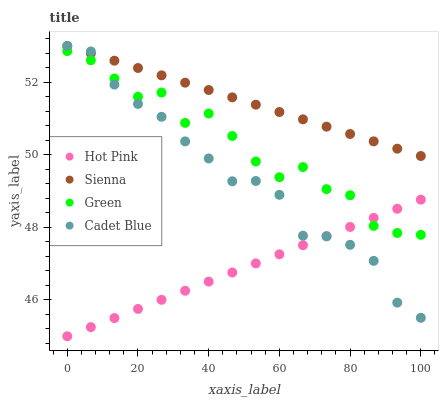Does Hot Pink have the minimum area under the curve?
Answer yes or no. Yes. Does Sienna have the maximum area under the curve?
Answer yes or no. Yes. Does Green have the minimum area under the curve?
Answer yes or no. No. Does Green have the maximum area under the curve?
Answer yes or no. No. Is Hot Pink the smoothest?
Answer yes or no. Yes. Is Green the roughest?
Answer yes or no. Yes. Is Green the smoothest?
Answer yes or no. No. Is Hot Pink the roughest?
Answer yes or no. No. Does Hot Pink have the lowest value?
Answer yes or no. Yes. Does Green have the lowest value?
Answer yes or no. No. Does Cadet Blue have the highest value?
Answer yes or no. Yes. Does Green have the highest value?
Answer yes or no. No. Is Green less than Sienna?
Answer yes or no. Yes. Is Sienna greater than Green?
Answer yes or no. Yes. Does Sienna intersect Cadet Blue?
Answer yes or no. Yes. Is Sienna less than Cadet Blue?
Answer yes or no. No. Is Sienna greater than Cadet Blue?
Answer yes or no. No. Does Green intersect Sienna?
Answer yes or no. No. 